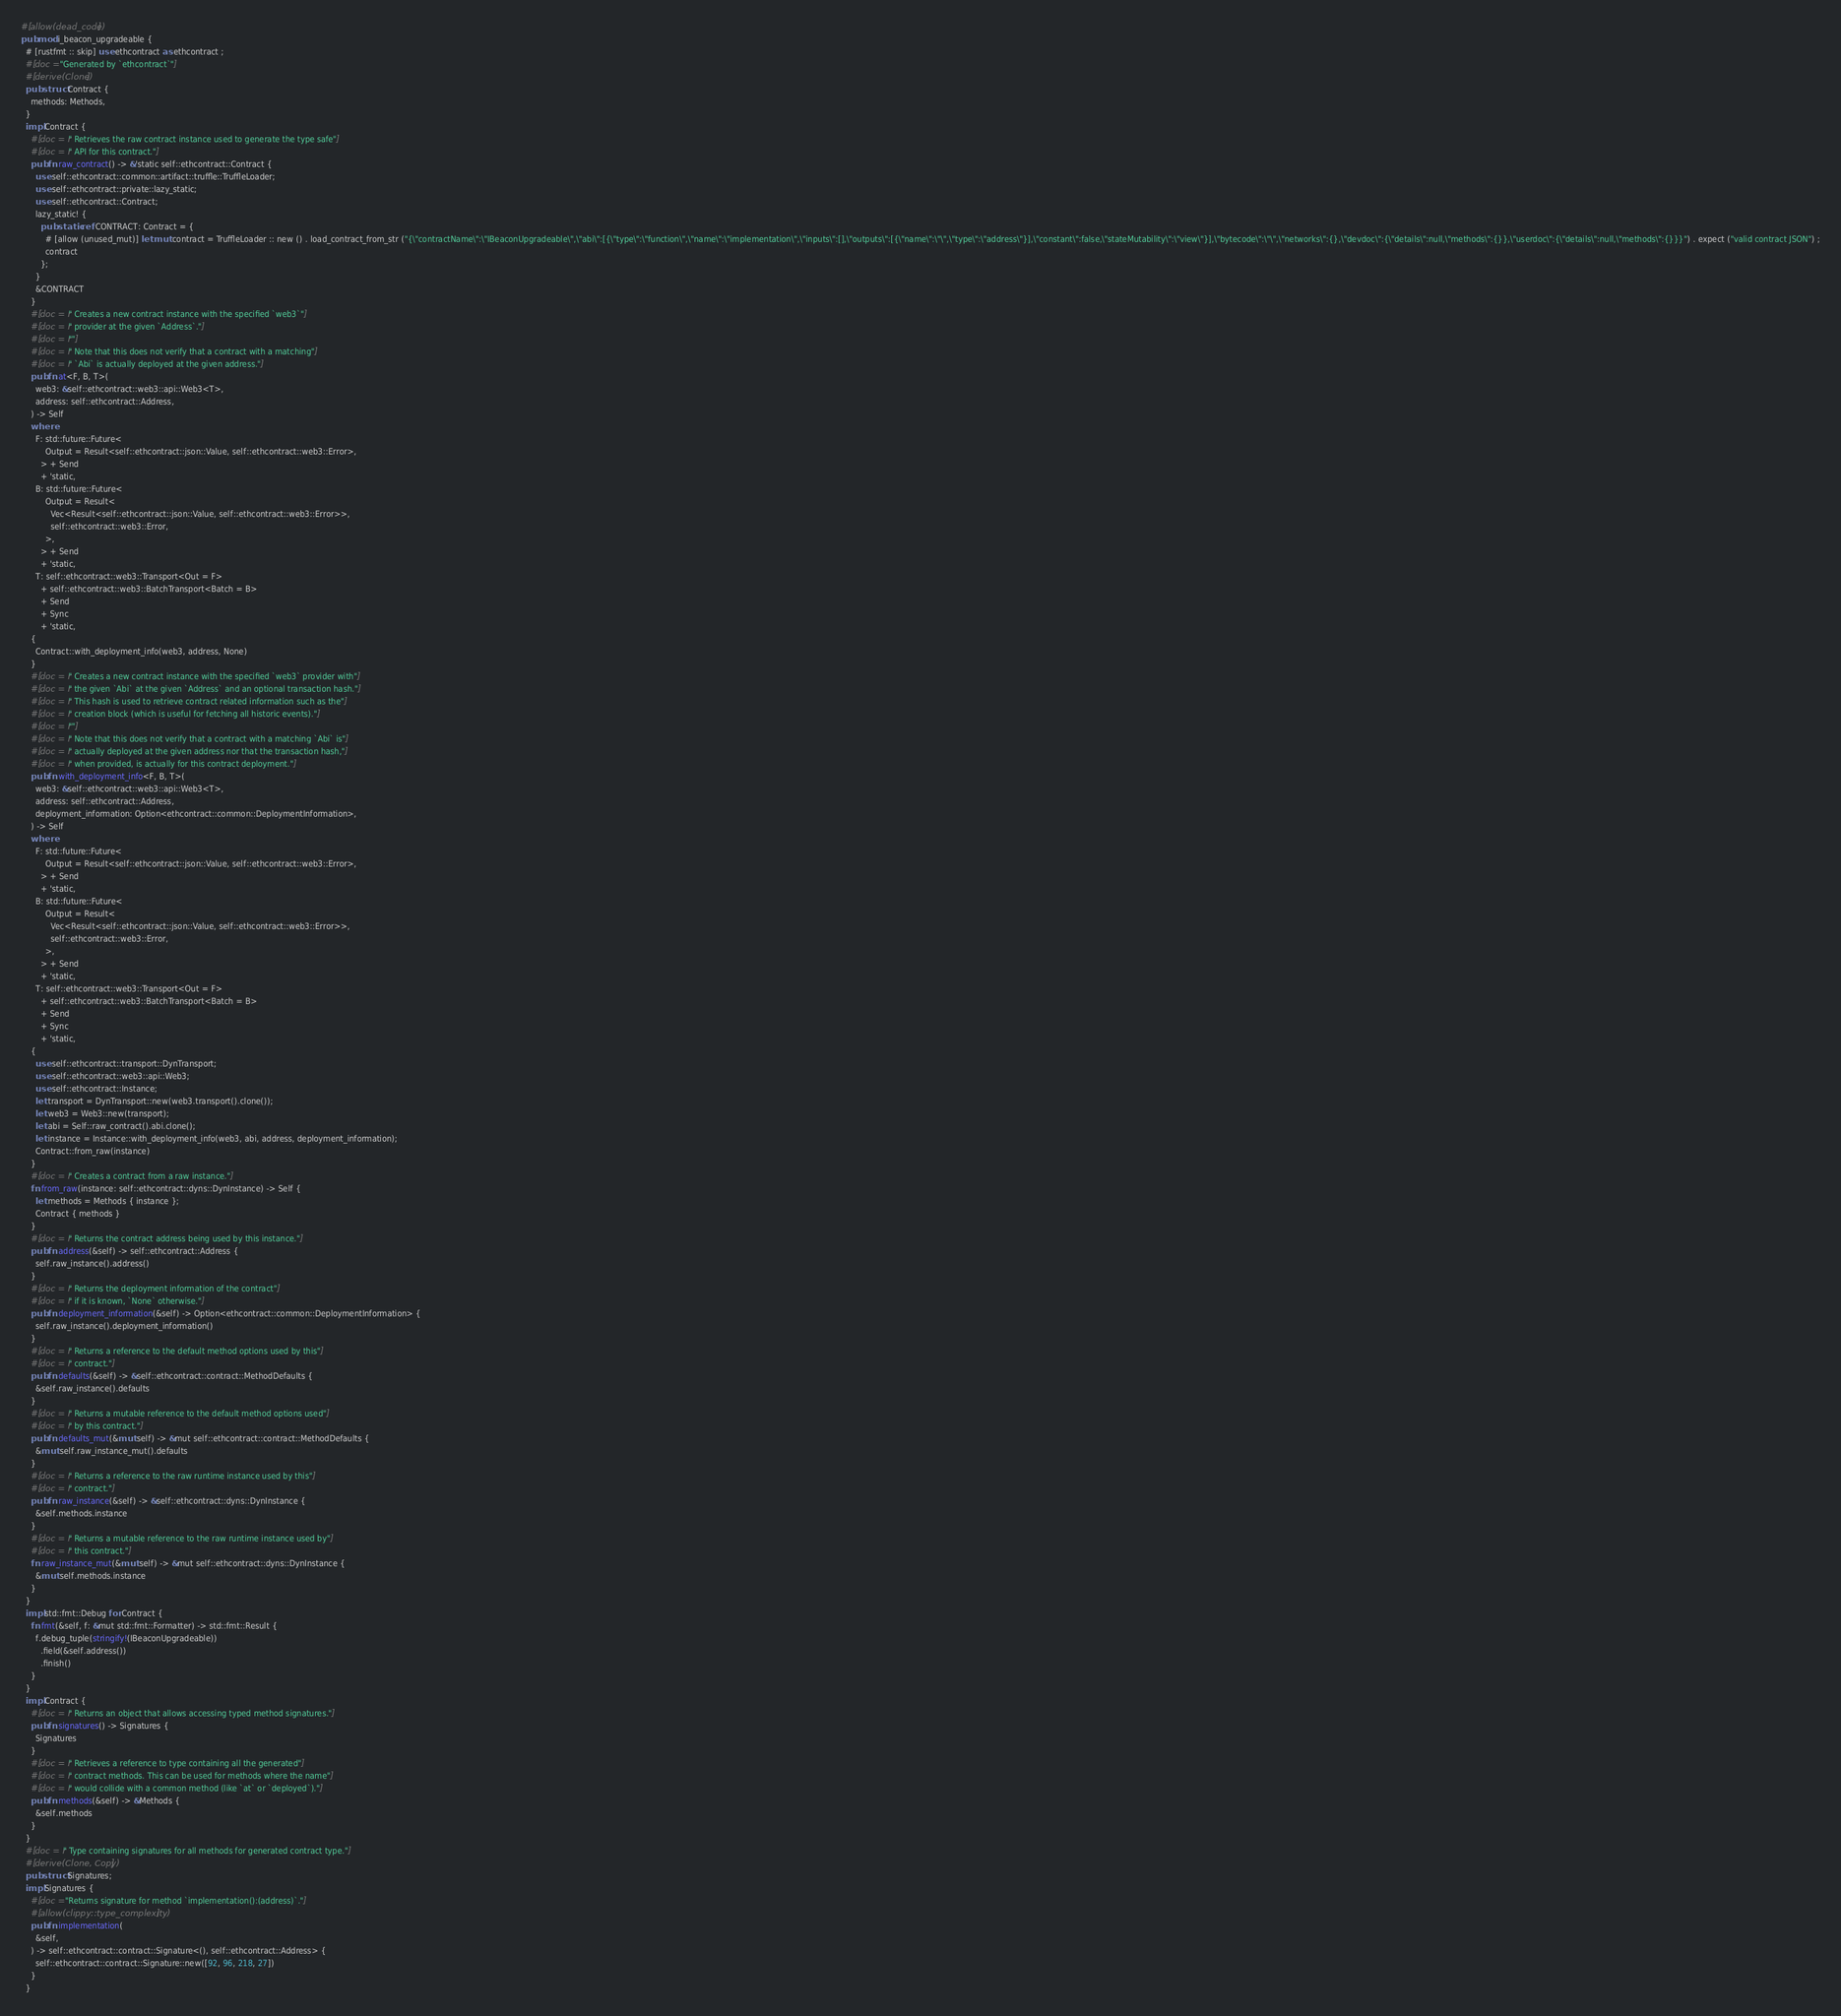<code> <loc_0><loc_0><loc_500><loc_500><_Rust_>#[allow(dead_code)]
pub mod i_beacon_upgradeable {
  # [rustfmt :: skip] use ethcontract as ethcontract ;
  #[doc = "Generated by `ethcontract`"]
  #[derive(Clone)]
  pub struct Contract {
    methods: Methods,
  }
  impl Contract {
    #[doc = r" Retrieves the raw contract instance used to generate the type safe"]
    #[doc = r" API for this contract."]
    pub fn raw_contract() -> &'static self::ethcontract::Contract {
      use self::ethcontract::common::artifact::truffle::TruffleLoader;
      use self::ethcontract::private::lazy_static;
      use self::ethcontract::Contract;
      lazy_static! {
        pub static ref CONTRACT: Contract = {
          # [allow (unused_mut)] let mut contract = TruffleLoader :: new () . load_contract_from_str ("{\"contractName\":\"IBeaconUpgradeable\",\"abi\":[{\"type\":\"function\",\"name\":\"implementation\",\"inputs\":[],\"outputs\":[{\"name\":\"\",\"type\":\"address\"}],\"constant\":false,\"stateMutability\":\"view\"}],\"bytecode\":\"\",\"networks\":{},\"devdoc\":{\"details\":null,\"methods\":{}},\"userdoc\":{\"details\":null,\"methods\":{}}}") . expect ("valid contract JSON") ;
          contract
        };
      }
      &CONTRACT
    }
    #[doc = r" Creates a new contract instance with the specified `web3`"]
    #[doc = r" provider at the given `Address`."]
    #[doc = r""]
    #[doc = r" Note that this does not verify that a contract with a matching"]
    #[doc = r" `Abi` is actually deployed at the given address."]
    pub fn at<F, B, T>(
      web3: &self::ethcontract::web3::api::Web3<T>,
      address: self::ethcontract::Address,
    ) -> Self
    where
      F: std::future::Future<
          Output = Result<self::ethcontract::json::Value, self::ethcontract::web3::Error>,
        > + Send
        + 'static,
      B: std::future::Future<
          Output = Result<
            Vec<Result<self::ethcontract::json::Value, self::ethcontract::web3::Error>>,
            self::ethcontract::web3::Error,
          >,
        > + Send
        + 'static,
      T: self::ethcontract::web3::Transport<Out = F>
        + self::ethcontract::web3::BatchTransport<Batch = B>
        + Send
        + Sync
        + 'static,
    {
      Contract::with_deployment_info(web3, address, None)
    }
    #[doc = r" Creates a new contract instance with the specified `web3` provider with"]
    #[doc = r" the given `Abi` at the given `Address` and an optional transaction hash."]
    #[doc = r" This hash is used to retrieve contract related information such as the"]
    #[doc = r" creation block (which is useful for fetching all historic events)."]
    #[doc = r""]
    #[doc = r" Note that this does not verify that a contract with a matching `Abi` is"]
    #[doc = r" actually deployed at the given address nor that the transaction hash,"]
    #[doc = r" when provided, is actually for this contract deployment."]
    pub fn with_deployment_info<F, B, T>(
      web3: &self::ethcontract::web3::api::Web3<T>,
      address: self::ethcontract::Address,
      deployment_information: Option<ethcontract::common::DeploymentInformation>,
    ) -> Self
    where
      F: std::future::Future<
          Output = Result<self::ethcontract::json::Value, self::ethcontract::web3::Error>,
        > + Send
        + 'static,
      B: std::future::Future<
          Output = Result<
            Vec<Result<self::ethcontract::json::Value, self::ethcontract::web3::Error>>,
            self::ethcontract::web3::Error,
          >,
        > + Send
        + 'static,
      T: self::ethcontract::web3::Transport<Out = F>
        + self::ethcontract::web3::BatchTransport<Batch = B>
        + Send
        + Sync
        + 'static,
    {
      use self::ethcontract::transport::DynTransport;
      use self::ethcontract::web3::api::Web3;
      use self::ethcontract::Instance;
      let transport = DynTransport::new(web3.transport().clone());
      let web3 = Web3::new(transport);
      let abi = Self::raw_contract().abi.clone();
      let instance = Instance::with_deployment_info(web3, abi, address, deployment_information);
      Contract::from_raw(instance)
    }
    #[doc = r" Creates a contract from a raw instance."]
    fn from_raw(instance: self::ethcontract::dyns::DynInstance) -> Self {
      let methods = Methods { instance };
      Contract { methods }
    }
    #[doc = r" Returns the contract address being used by this instance."]
    pub fn address(&self) -> self::ethcontract::Address {
      self.raw_instance().address()
    }
    #[doc = r" Returns the deployment information of the contract"]
    #[doc = r" if it is known, `None` otherwise."]
    pub fn deployment_information(&self) -> Option<ethcontract::common::DeploymentInformation> {
      self.raw_instance().deployment_information()
    }
    #[doc = r" Returns a reference to the default method options used by this"]
    #[doc = r" contract."]
    pub fn defaults(&self) -> &self::ethcontract::contract::MethodDefaults {
      &self.raw_instance().defaults
    }
    #[doc = r" Returns a mutable reference to the default method options used"]
    #[doc = r" by this contract."]
    pub fn defaults_mut(&mut self) -> &mut self::ethcontract::contract::MethodDefaults {
      &mut self.raw_instance_mut().defaults
    }
    #[doc = r" Returns a reference to the raw runtime instance used by this"]
    #[doc = r" contract."]
    pub fn raw_instance(&self) -> &self::ethcontract::dyns::DynInstance {
      &self.methods.instance
    }
    #[doc = r" Returns a mutable reference to the raw runtime instance used by"]
    #[doc = r" this contract."]
    fn raw_instance_mut(&mut self) -> &mut self::ethcontract::dyns::DynInstance {
      &mut self.methods.instance
    }
  }
  impl std::fmt::Debug for Contract {
    fn fmt(&self, f: &mut std::fmt::Formatter) -> std::fmt::Result {
      f.debug_tuple(stringify!(IBeaconUpgradeable))
        .field(&self.address())
        .finish()
    }
  }
  impl Contract {
    #[doc = r" Returns an object that allows accessing typed method signatures."]
    pub fn signatures() -> Signatures {
      Signatures
    }
    #[doc = r" Retrieves a reference to type containing all the generated"]
    #[doc = r" contract methods. This can be used for methods where the name"]
    #[doc = r" would collide with a common method (like `at` or `deployed`)."]
    pub fn methods(&self) -> &Methods {
      &self.methods
    }
  }
  #[doc = r" Type containing signatures for all methods for generated contract type."]
  #[derive(Clone, Copy)]
  pub struct Signatures;
  impl Signatures {
    #[doc = "Returns signature for method `implementation():(address)`."]
    #[allow(clippy::type_complexity)]
    pub fn implementation(
      &self,
    ) -> self::ethcontract::contract::Signature<(), self::ethcontract::Address> {
      self::ethcontract::contract::Signature::new([92, 96, 218, 27])
    }
  }</code> 